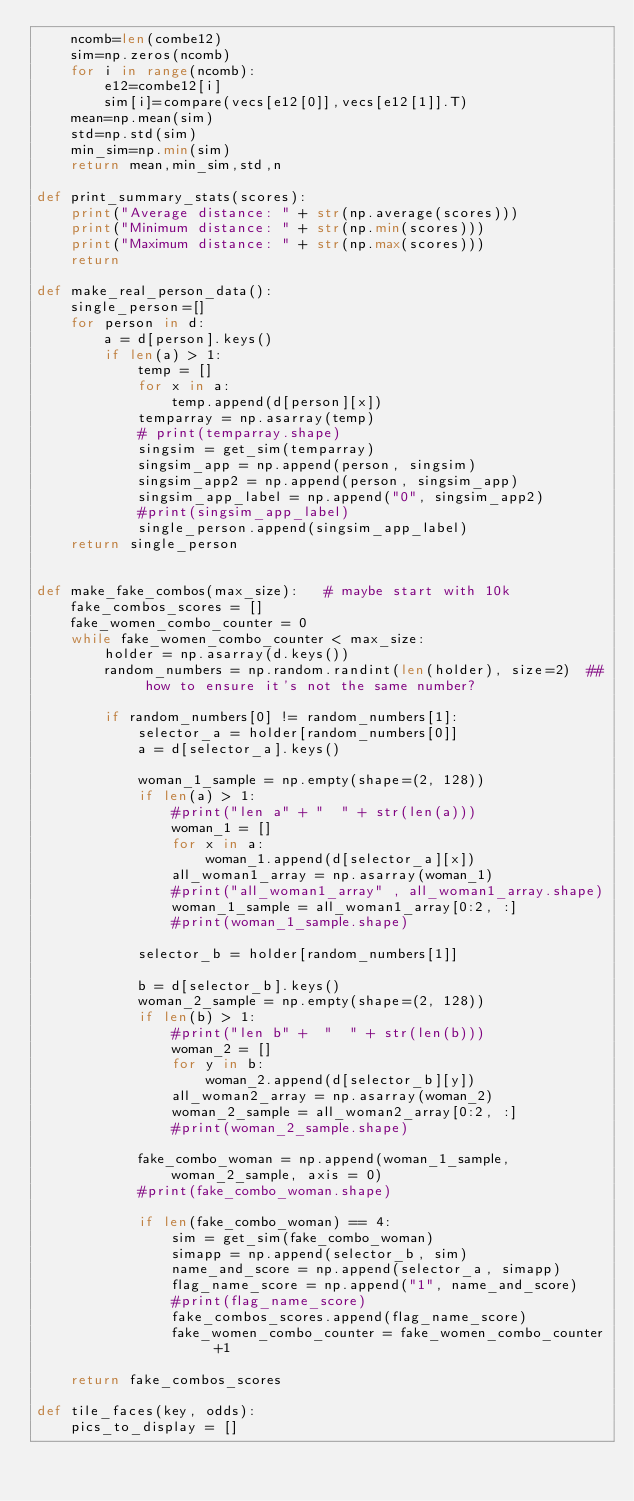<code> <loc_0><loc_0><loc_500><loc_500><_Python_>    ncomb=len(combe12)
    sim=np.zeros(ncomb)
    for i in range(ncomb):
        e12=combe12[i]
        sim[i]=compare(vecs[e12[0]],vecs[e12[1]].T)
    mean=np.mean(sim)
    std=np.std(sim)
    min_sim=np.min(sim)
    return mean,min_sim,std,n

def print_summary_stats(scores):
    print("Average distance: " + str(np.average(scores)))
    print("Minimum distance: " + str(np.min(scores)))
    print("Maximum distance: " + str(np.max(scores)))
    return

def make_real_person_data():
    single_person=[]
    for person in d:
        a = d[person].keys()
        if len(a) > 1:
            temp = []
            for x in a:
                temp.append(d[person][x])
            temparray = np.asarray(temp)
            # print(temparray.shape)
            singsim = get_sim(temparray)
            singsim_app = np.append(person, singsim)
            singsim_app2 = np.append(person, singsim_app)
            singsim_app_label = np.append("0", singsim_app2)
            #print(singsim_app_label)
            single_person.append(singsim_app_label)
    return single_person


def make_fake_combos(max_size):   # maybe start with 10k
    fake_combos_scores = []
    fake_women_combo_counter = 0
    while fake_women_combo_counter < max_size:
        holder = np.asarray(d.keys())
        random_numbers = np.random.randint(len(holder), size=2)  ## how to ensure it's not the same number?

        if random_numbers[0] != random_numbers[1]:
            selector_a = holder[random_numbers[0]]
            a = d[selector_a].keys()

            woman_1_sample = np.empty(shape=(2, 128))
            if len(a) > 1:
                #print("len a" + "  " + str(len(a)))
                woman_1 = []
                for x in a:
                    woman_1.append(d[selector_a][x])
                all_woman1_array = np.asarray(woman_1)
                #print("all_woman1_array" , all_woman1_array.shape)
                woman_1_sample = all_woman1_array[0:2, :]
                #print(woman_1_sample.shape)

            selector_b = holder[random_numbers[1]]

            b = d[selector_b].keys()
            woman_2_sample = np.empty(shape=(2, 128))
            if len(b) > 1:
                #print("len b" +  "  " + str(len(b)))
                woman_2 = []
                for y in b:
                    woman_2.append(d[selector_b][y])
                all_woman2_array = np.asarray(woman_2)
                woman_2_sample = all_woman2_array[0:2, :]
                #print(woman_2_sample.shape)

            fake_combo_woman = np.append(woman_1_sample, woman_2_sample, axis = 0)
            #print(fake_combo_woman.shape)

            if len(fake_combo_woman) == 4:
                sim = get_sim(fake_combo_woman)
                simapp = np.append(selector_b, sim)
                name_and_score = np.append(selector_a, simapp)
                flag_name_score = np.append("1", name_and_score)
                #print(flag_name_score)
                fake_combos_scores.append(flag_name_score)
                fake_women_combo_counter = fake_women_combo_counter +1

    return fake_combos_scores

def tile_faces(key, odds):
    pics_to_display = []</code> 